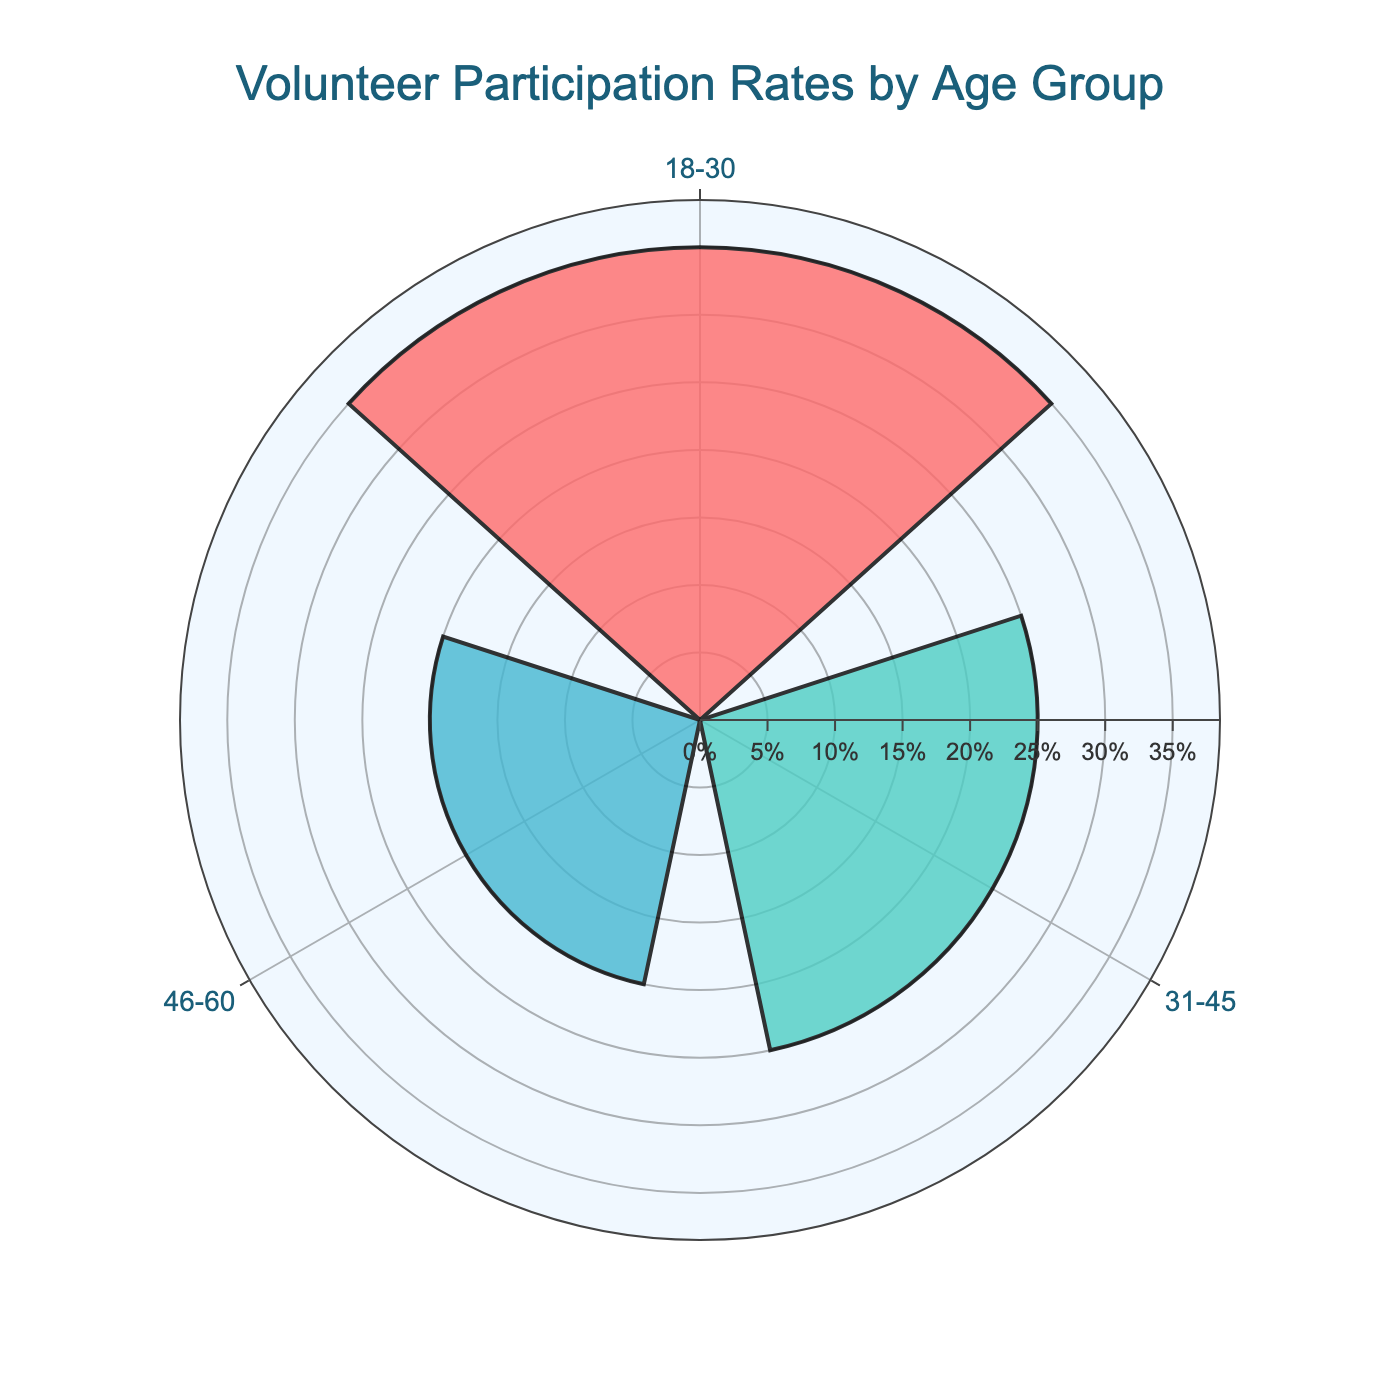What is the title of the figure? The title is displayed prominently at the top of the figure. It reads "Volunteer Participation Rates by Age Group".
Answer: Volunteer Participation Rates by Age Group How many age groups are displayed in this chart? By looking at the radial axis, there are 3 groups represented in the chart.
Answer: 3 Which age group has the highest volunteer participation rate? The group with the largest bar extending from the center of the chart indicates the highest participation rate. This is the 18-30 age group.
Answer: 18-30 What percentage of participation does the 31-45 age group exhibit? From the bars, the value associated with the 31-45 age group can be read directly. The bar extends to 25%.
Answer: 25% Are the participation rates for the 46-60 and 60+ age groups included in this chart? The chart only shows the top 3 age groups based on participation rates, and since only 18-30, 31-45, and 46-60 are shown, the 60+ group is excluded.
Answer: No Which age group has the least participation among those displayed? The smallest bar indicates the least participation rate in this chart, which corresponds to the 46-60 age group.
Answer: 46-60 What is the difference in participation rates between the age group with the highest and the lowest participation? The highest participation rate is 35% (18-30) and the lowest is 20% (46-60). The difference is calculated as 35% - 20%.
Answer: 15% What is the average participation rate of the age groups displayed in the chart? Add the participation rates of 18-30 (35%), 31-45 (25%), and 46-60 (20%) and then divide by 3 to find the average: (35 + 25 + 20) / 3.
Answer: 26.67% Does the participation rate of the 18-30 age group exceed the sum of those of the other two groups combined? Calculate the sum of participation rates of the 31-45 and 46-60 groups: 25% + 20% = 45%. The 18-30 group at 35% does not exceed 45%.
Answer: No What color represents the 31-45 age group in this chart? The bar corresponding to the 31-45 age group is in a turquoise color.
Answer: Turquoise 